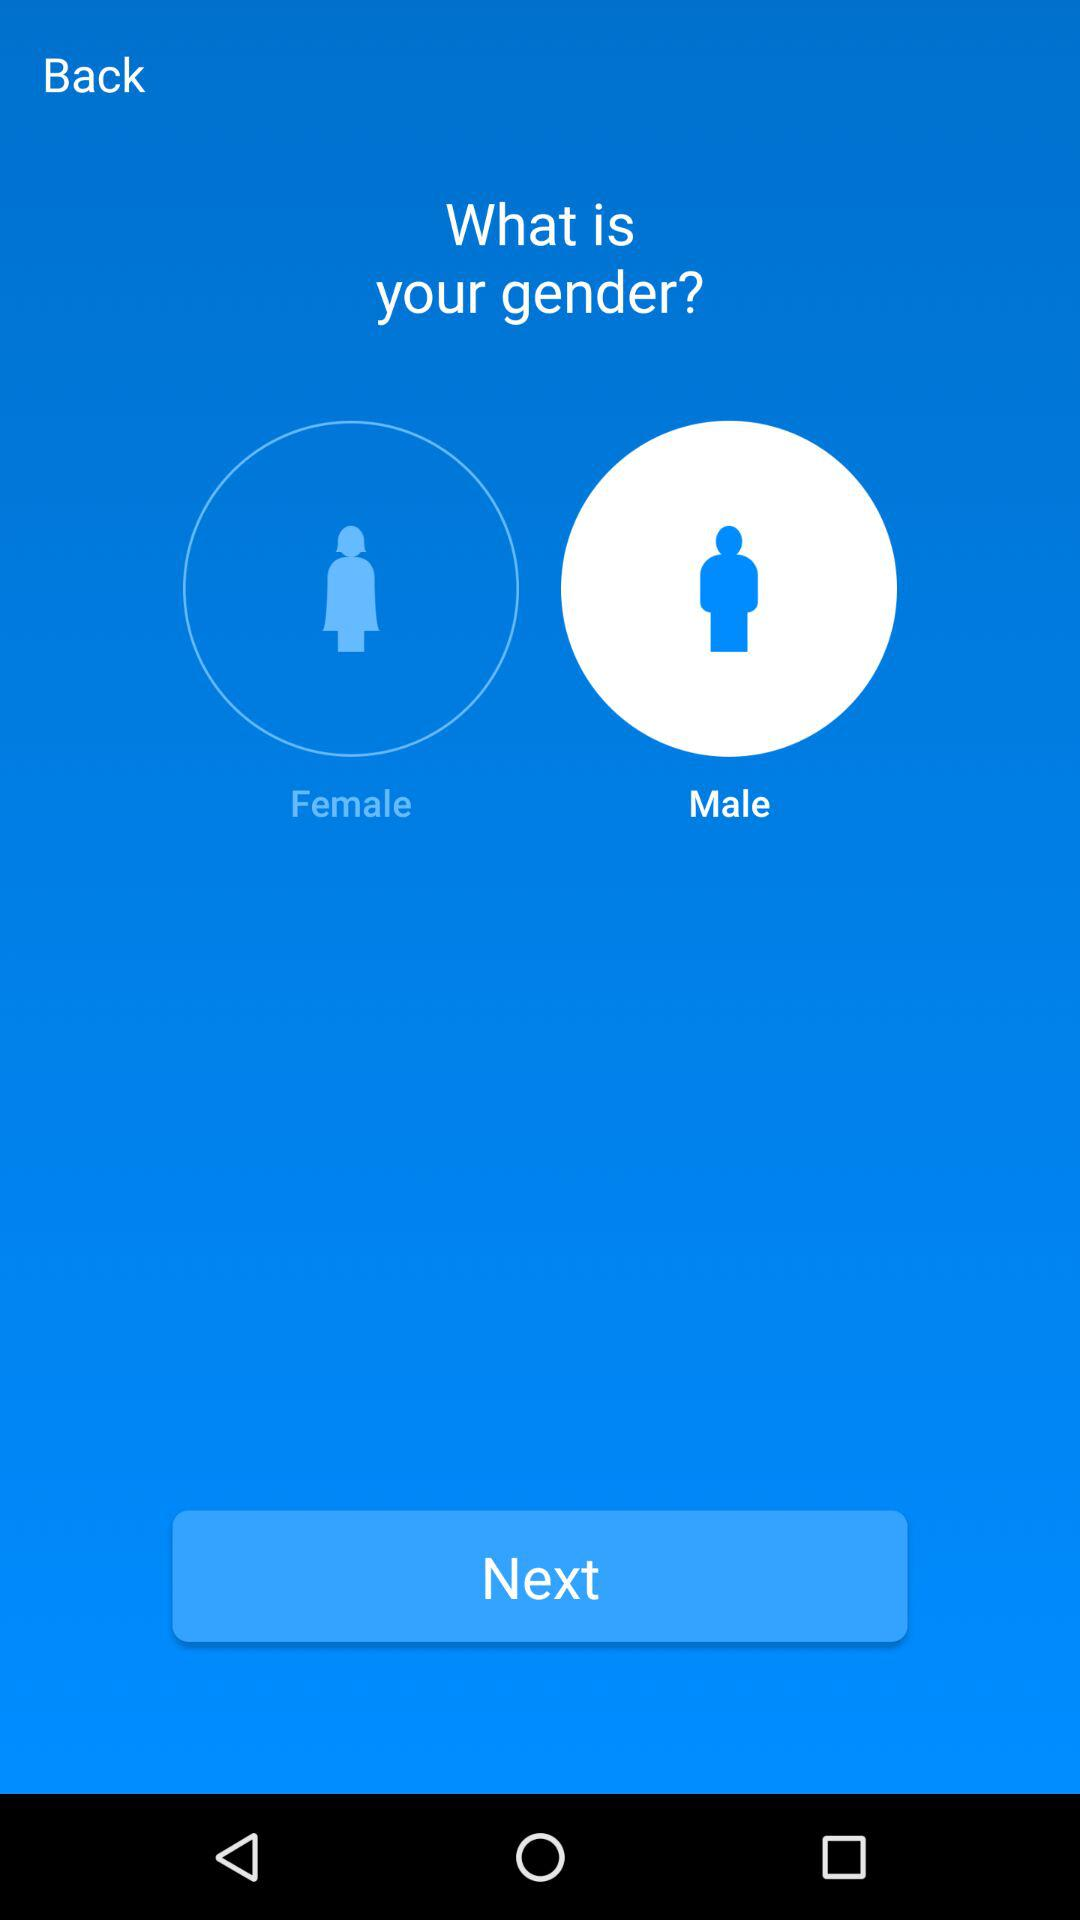Which gender option is selected? The selected gender is male. 